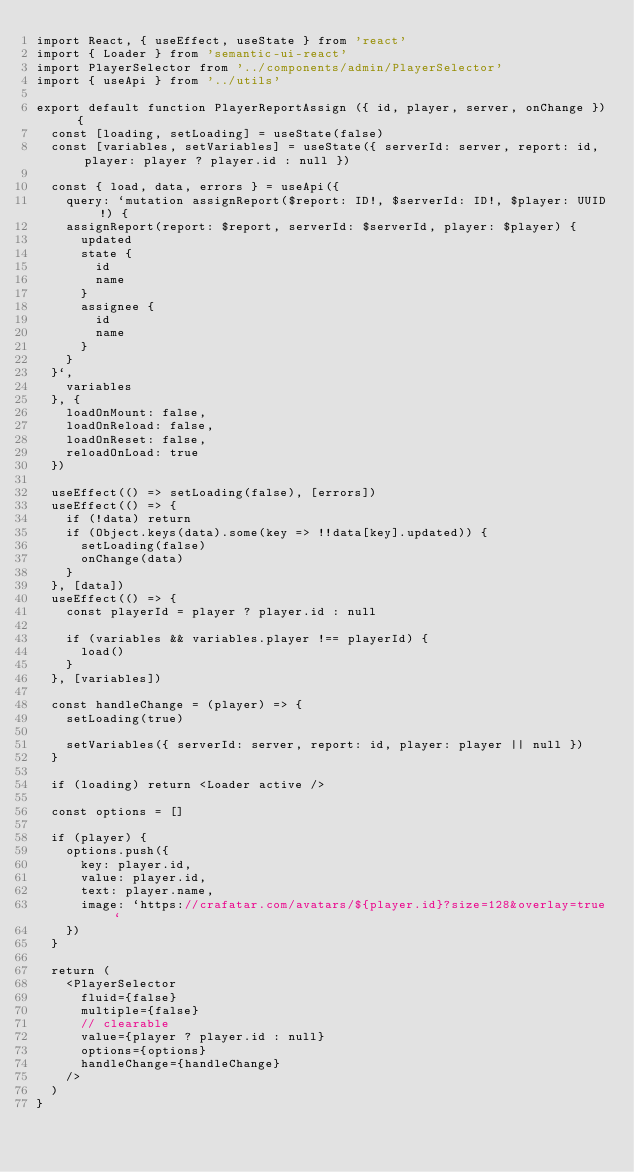<code> <loc_0><loc_0><loc_500><loc_500><_JavaScript_>import React, { useEffect, useState } from 'react'
import { Loader } from 'semantic-ui-react'
import PlayerSelector from '../components/admin/PlayerSelector'
import { useApi } from '../utils'

export default function PlayerReportAssign ({ id, player, server, onChange }) {
  const [loading, setLoading] = useState(false)
  const [variables, setVariables] = useState({ serverId: server, report: id, player: player ? player.id : null })

  const { load, data, errors } = useApi({
    query: `mutation assignReport($report: ID!, $serverId: ID!, $player: UUID!) {
    assignReport(report: $report, serverId: $serverId, player: $player) {
      updated
      state {
        id
        name
      }
      assignee {
        id
        name
      }
    }
  }`,
    variables
  }, {
    loadOnMount: false,
    loadOnReload: false,
    loadOnReset: false,
    reloadOnLoad: true
  })

  useEffect(() => setLoading(false), [errors])
  useEffect(() => {
    if (!data) return
    if (Object.keys(data).some(key => !!data[key].updated)) {
      setLoading(false)
      onChange(data)
    }
  }, [data])
  useEffect(() => {
    const playerId = player ? player.id : null

    if (variables && variables.player !== playerId) {
      load()
    }
  }, [variables])

  const handleChange = (player) => {
    setLoading(true)

    setVariables({ serverId: server, report: id, player: player || null })
  }

  if (loading) return <Loader active />

  const options = []

  if (player) {
    options.push({
      key: player.id,
      value: player.id,
      text: player.name,
      image: `https://crafatar.com/avatars/${player.id}?size=128&overlay=true`
    })
  }

  return (
    <PlayerSelector
      fluid={false}
      multiple={false}
      // clearable
      value={player ? player.id : null}
      options={options}
      handleChange={handleChange}
    />
  )
}
</code> 